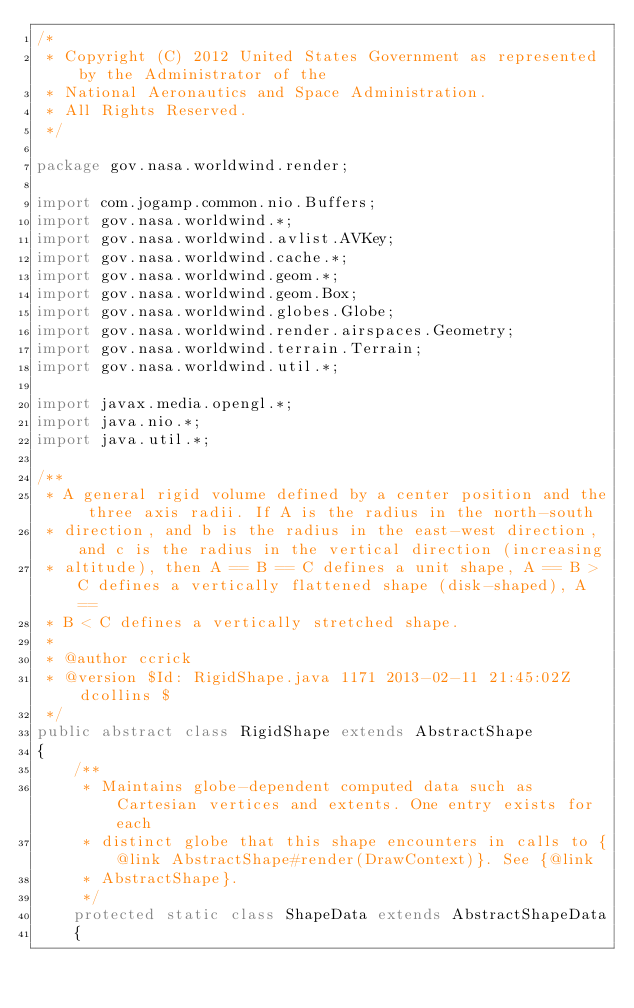<code> <loc_0><loc_0><loc_500><loc_500><_Java_>/*
 * Copyright (C) 2012 United States Government as represented by the Administrator of the
 * National Aeronautics and Space Administration.
 * All Rights Reserved.
 */

package gov.nasa.worldwind.render;

import com.jogamp.common.nio.Buffers;
import gov.nasa.worldwind.*;
import gov.nasa.worldwind.avlist.AVKey;
import gov.nasa.worldwind.cache.*;
import gov.nasa.worldwind.geom.*;
import gov.nasa.worldwind.geom.Box;
import gov.nasa.worldwind.globes.Globe;
import gov.nasa.worldwind.render.airspaces.Geometry;
import gov.nasa.worldwind.terrain.Terrain;
import gov.nasa.worldwind.util.*;

import javax.media.opengl.*;
import java.nio.*;
import java.util.*;

/**
 * A general rigid volume defined by a center position and the three axis radii. If A is the radius in the north-south
 * direction, and b is the radius in the east-west direction, and c is the radius in the vertical direction (increasing
 * altitude), then A == B == C defines a unit shape, A == B > C defines a vertically flattened shape (disk-shaped), A ==
 * B < C defines a vertically stretched shape.
 *
 * @author ccrick
 * @version $Id: RigidShape.java 1171 2013-02-11 21:45:02Z dcollins $
 */
public abstract class RigidShape extends AbstractShape
{
    /**
     * Maintains globe-dependent computed data such as Cartesian vertices and extents. One entry exists for each
     * distinct globe that this shape encounters in calls to {@link AbstractShape#render(DrawContext)}. See {@link
     * AbstractShape}.
     */
    protected static class ShapeData extends AbstractShapeData
    {</code> 